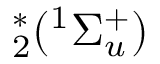Convert formula to latex. <formula><loc_0><loc_0><loc_500><loc_500>^ { * } _ { 2 } ( ^ { 1 } \Sigma _ { u } ^ { + } )</formula> 